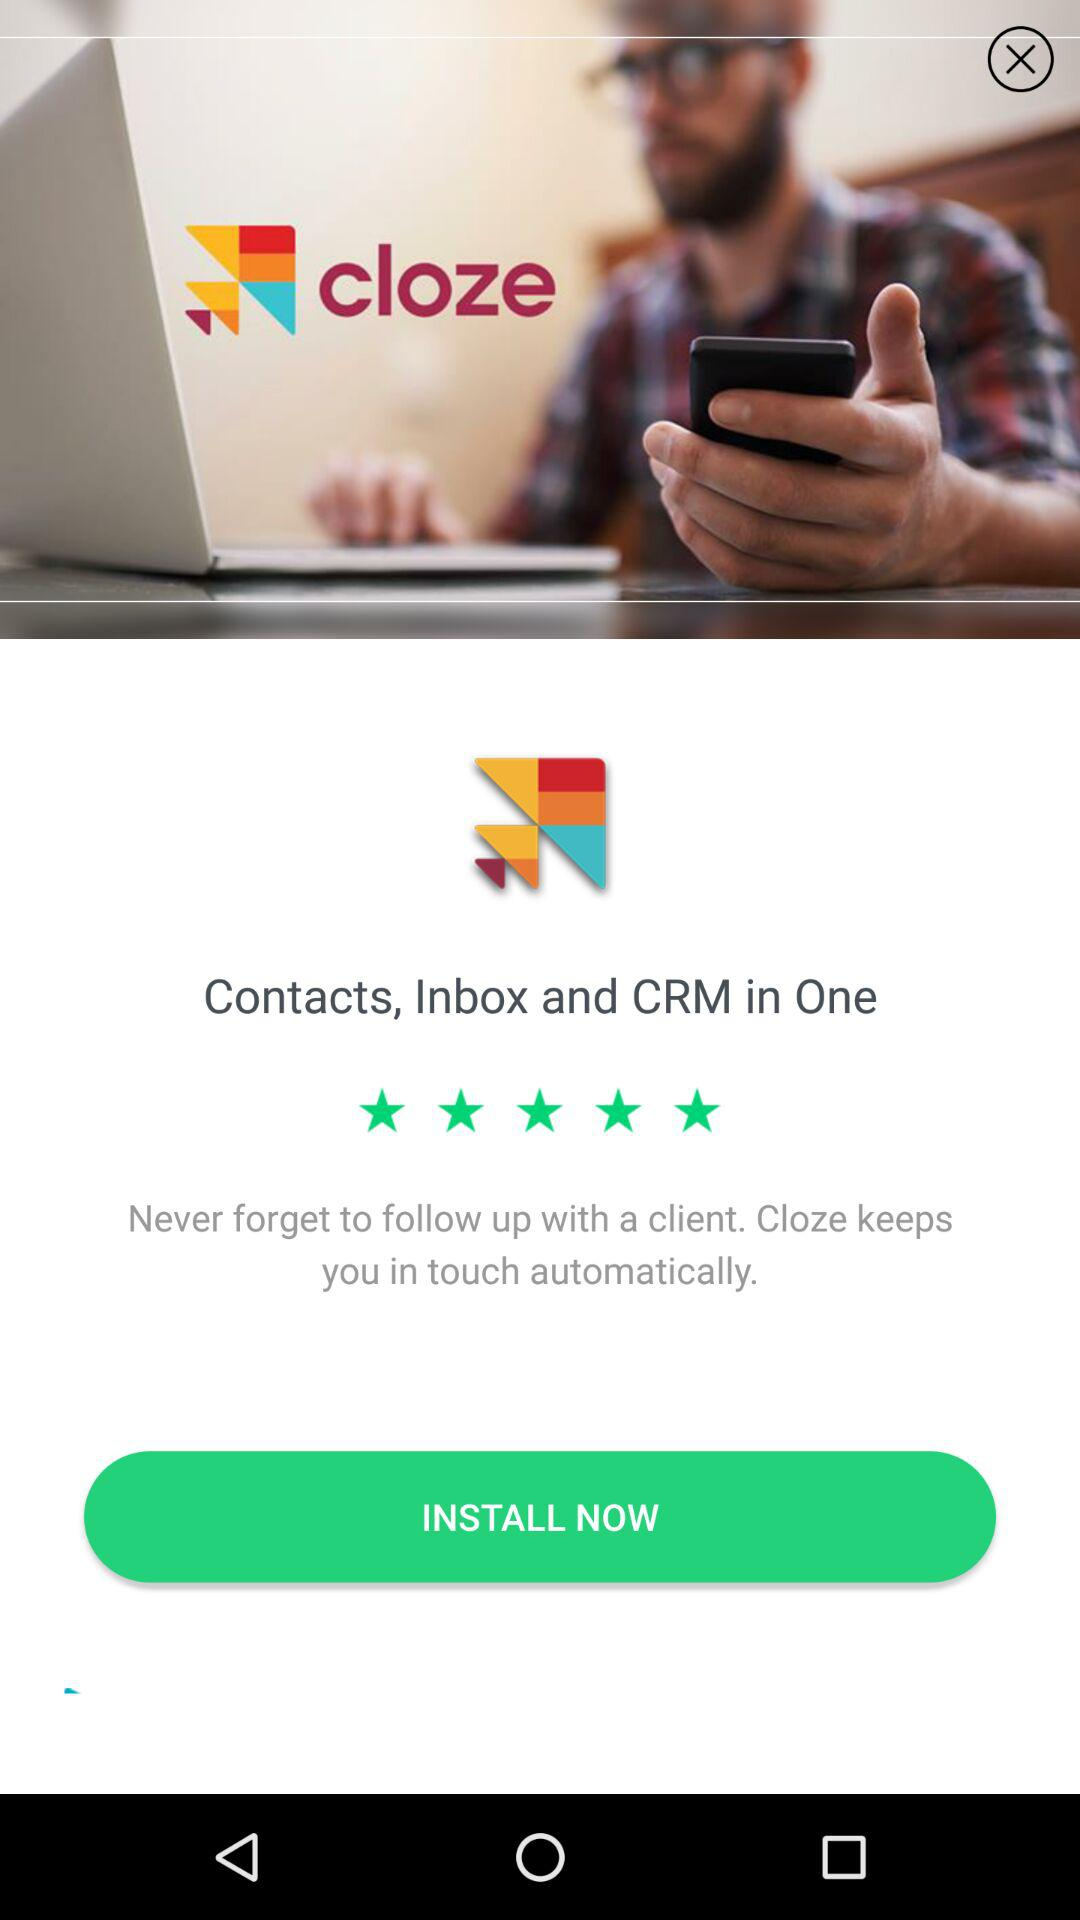What is the name of the application? The name of the application is "cloze". 